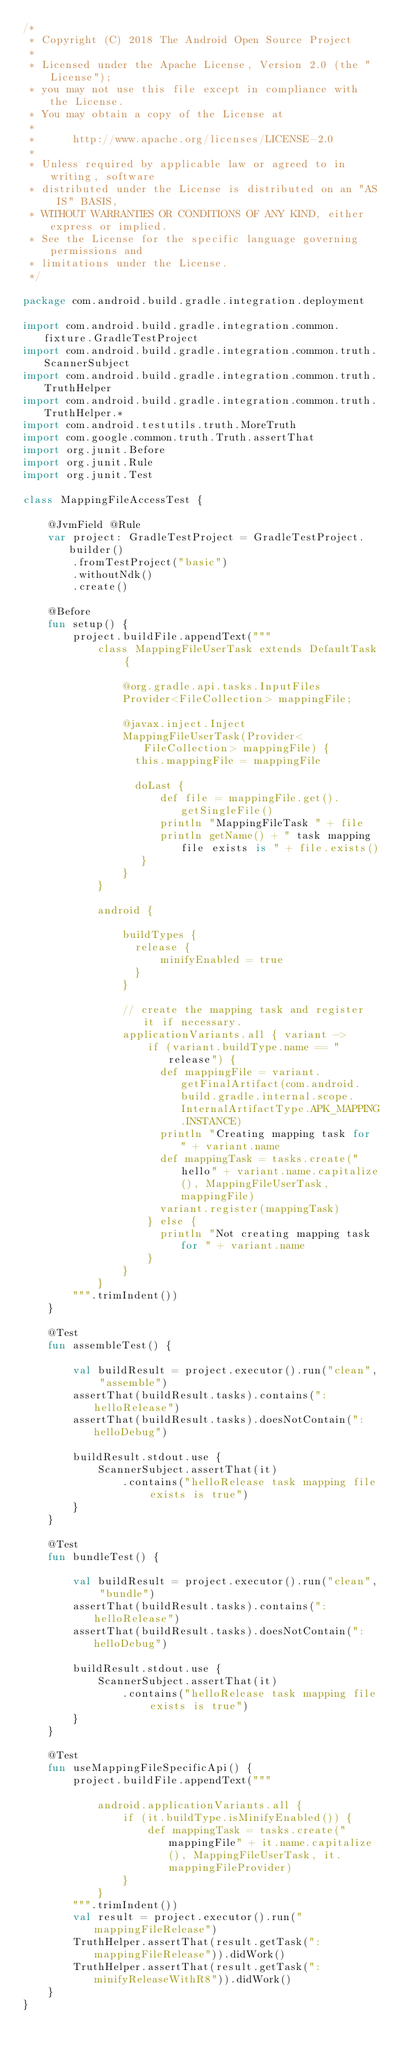<code> <loc_0><loc_0><loc_500><loc_500><_Kotlin_>/*
 * Copyright (C) 2018 The Android Open Source Project
 *
 * Licensed under the Apache License, Version 2.0 (the "License");
 * you may not use this file except in compliance with the License.
 * You may obtain a copy of the License at
 *
 *      http://www.apache.org/licenses/LICENSE-2.0
 *
 * Unless required by applicable law or agreed to in writing, software
 * distributed under the License is distributed on an "AS IS" BASIS,
 * WITHOUT WARRANTIES OR CONDITIONS OF ANY KIND, either express or implied.
 * See the License for the specific language governing permissions and
 * limitations under the License.
 */

package com.android.build.gradle.integration.deployment

import com.android.build.gradle.integration.common.fixture.GradleTestProject
import com.android.build.gradle.integration.common.truth.ScannerSubject
import com.android.build.gradle.integration.common.truth.TruthHelper
import com.android.build.gradle.integration.common.truth.TruthHelper.*
import com.android.testutils.truth.MoreTruth
import com.google.common.truth.Truth.assertThat
import org.junit.Before
import org.junit.Rule
import org.junit.Test

class MappingFileAccessTest {

    @JvmField @Rule
    var project: GradleTestProject = GradleTestProject.builder()
        .fromTestProject("basic")
        .withoutNdk()
        .create()

    @Before
    fun setup() {
        project.buildFile.appendText("""
            class MappingFileUserTask extends DefaultTask {

                @org.gradle.api.tasks.InputFiles
                Provider<FileCollection> mappingFile;

                @javax.inject.Inject
                MappingFileUserTask(Provider<FileCollection> mappingFile) {
                  this.mappingFile = mappingFile

                  doLast {
                      def file = mappingFile.get().getSingleFile()
                      println "MappingFileTask " + file
                      println getName() + " task mapping file exists is " + file.exists()
                   }
                }
            }

            android {

                buildTypes {
                  release {
                      minifyEnabled = true
                  }
                }

                // create the mapping task and register it if necessary.
                applicationVariants.all { variant ->
                    if (variant.buildType.name == "release") {
                      def mappingFile = variant.getFinalArtifact(com.android.build.gradle.internal.scope.InternalArtifactType.APK_MAPPING.INSTANCE)
                      println "Creating mapping task for " + variant.name
                      def mappingTask = tasks.create("hello" + variant.name.capitalize(), MappingFileUserTask, mappingFile)
                      variant.register(mappingTask)
                    } else {
                      println "Not creating mapping task for " + variant.name
                    }
                }
            }
        """.trimIndent())
    }

    @Test
    fun assembleTest() {

        val buildResult = project.executor().run("clean", "assemble")
        assertThat(buildResult.tasks).contains(":helloRelease")
        assertThat(buildResult.tasks).doesNotContain(":helloDebug")

        buildResult.stdout.use {
            ScannerSubject.assertThat(it)
                .contains("helloRelease task mapping file exists is true")
        }
    }

    @Test
    fun bundleTest() {

        val buildResult = project.executor().run("clean", "bundle")
        assertThat(buildResult.tasks).contains(":helloRelease")
        assertThat(buildResult.tasks).doesNotContain(":helloDebug")

        buildResult.stdout.use {
            ScannerSubject.assertThat(it)
                .contains("helloRelease task mapping file exists is true")
        }
    }

    @Test
    fun useMappingFileSpecificApi() {
        project.buildFile.appendText("""
            
            android.applicationVariants.all {
                if (it.buildType.isMinifyEnabled()) {
                    def mappingTask = tasks.create("mappingFile" + it.name.capitalize(), MappingFileUserTask, it.mappingFileProvider)
                }
            }
        """.trimIndent())
        val result = project.executor().run("mappingFileRelease")
        TruthHelper.assertThat(result.getTask(":mappingFileRelease")).didWork()
        TruthHelper.assertThat(result.getTask(":minifyReleaseWithR8")).didWork()
    }
}</code> 